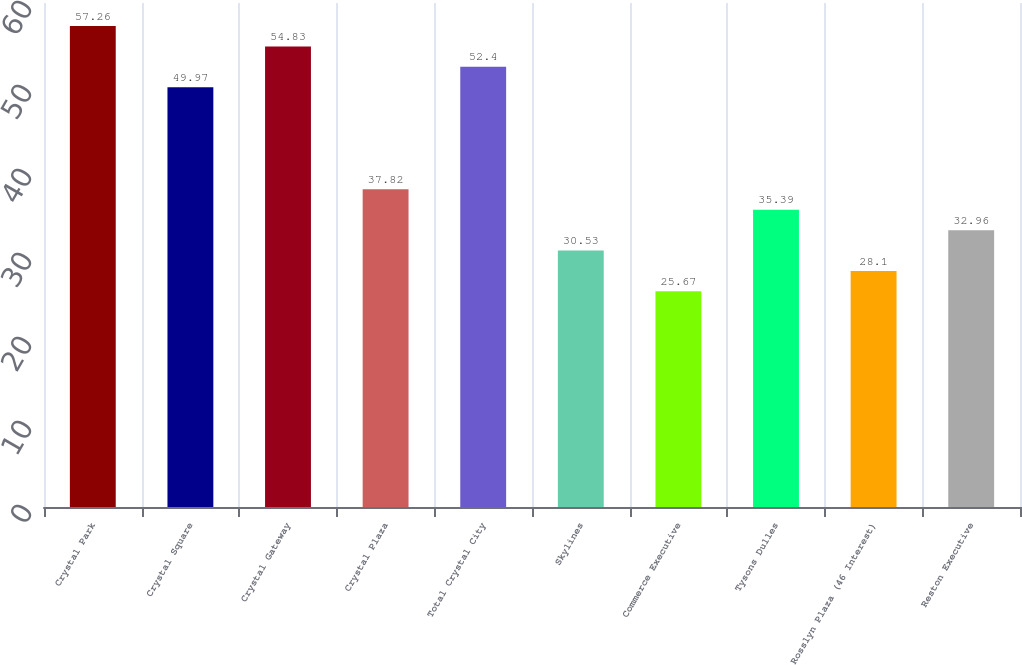Convert chart. <chart><loc_0><loc_0><loc_500><loc_500><bar_chart><fcel>Crystal Park<fcel>Crystal Square<fcel>Crystal Gateway<fcel>Crystal Plaza<fcel>Total Crystal City<fcel>Skylines<fcel>Commerce Executive<fcel>Tysons Dulles<fcel>Rosslyn Plaza (46 Interest)<fcel>Reston Executive<nl><fcel>57.26<fcel>49.97<fcel>54.83<fcel>37.82<fcel>52.4<fcel>30.53<fcel>25.67<fcel>35.39<fcel>28.1<fcel>32.96<nl></chart> 